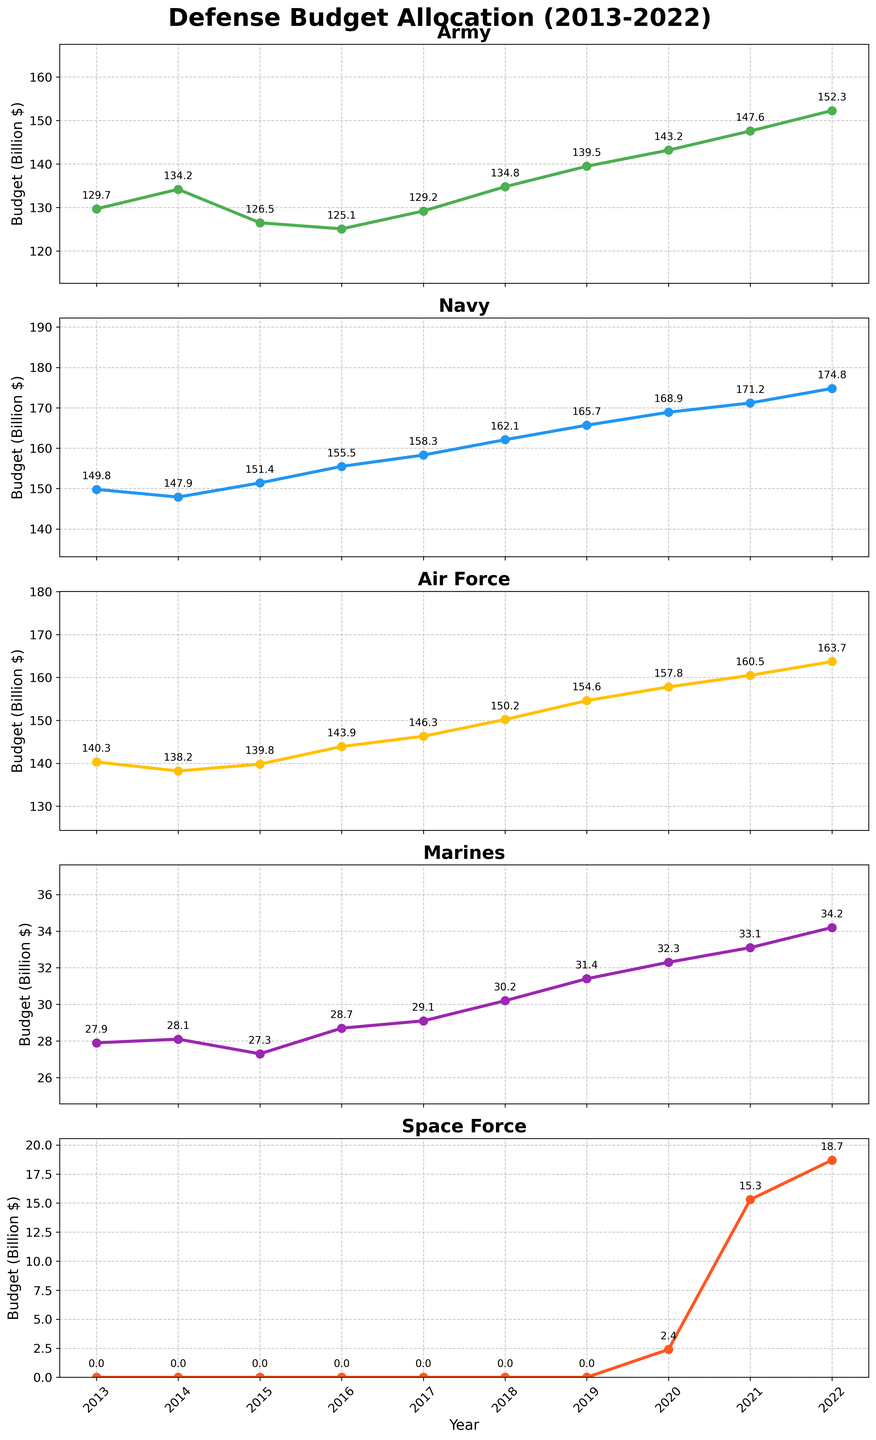What is the title of the figure? The title of the figure is found at the top and reads "Defense Budget Allocation (2013-2022)".
Answer: Defense Budget Allocation (2013-2022) What branch has the highest budget allocation in 2013? By examining the data points for 2013 across all subplots, the Navy has the highest budget allocation with around 149.8 billion dollars.
Answer: Navy How did the budget for the Army change from 2013 to 2022? By looking at the line for the Army from 2013 to 2022, it increases from 129.7 billion dollars in 2013 to 152.3 billion dollars in 2022.
Answer: Increased Which branch had the lowest budget in 2020? Looking at the subplots for the year 2020, the Marines have the lowest budget with a value of 32.3 billion dollars.
Answer: Marines What is the trend of the Space Force’s budget from 2020 to 2022? Observing the subplots for Space Force from 2020 to 2022, the budget increases from 2.4 billion dollars in 2020 to 18.7 billion dollars in 2022.
Answer: Increasing Which branch experienced the greatest increase in budget from 2018 to 2019? Comparing the difference in values from 2018 to 2019 for each branch, the Army increased from 134.8 to 139.5 billion dollars, the Navy increased from 162.1 to 165.7 billion dollars, the Air Force increased from 150.2 to 154.6 billion dollars, and the Marines increased from 30.2 to 31.4 billion dollars. The Army experienced the greatest increase (4.7 billion dollars).
Answer: Army How does the budget of the Marine Corps in 2019 compare to the Space Force in 2021? Referring to the subplots, the Marine Corps has a budget of 31.4 billion dollars in 2019, while the Space Force has a budget of 15.3 billion dollars in 2021. Comparing these values, the Marine Corps' budget is higher.
Answer: Marine Corps is higher What was the average budget for the Air Force over the decade? Adding up the values for the Air Force from 2013 to 2022 (140.3 + 138.2 + 139.8 + 143.9 + 146.3 + 150.2 + 154.6 + 157.8 + 160.5 + 163.7) gives 1455.3 billion dollars. Dividing by 10, the average budget is 145.53 billion dollars.
Answer: 145.53 billion dollars 